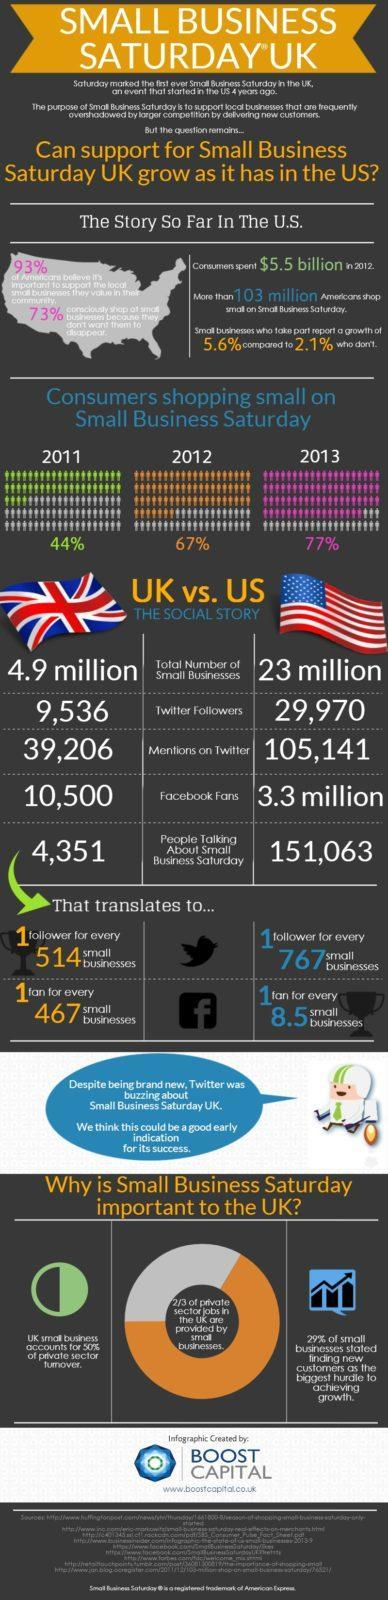What percentage of consumers were shopping small on Small Business Saturday in 2012?
Answer the question with a short phrase. 67% How many people were talking about the the Small Business Saturday in US? 151,063 What percentage of consumers were shopping small on Small Business Saturday in 2013? 77% How many fans are in facebook for every 467 small businesses in UK? 1 How many twitter mentions were received by the Small Business Saturday in UK? 39,206 How many twitter followers are there for the Small Business Saturday in UK? 9,536 What is the total number of small businesses that took part in Small Business Saturday in US? 23 MILLION What percentage of private sector turnover is contributed by the UK small business? 50% How many facebook fans are there for the Small Business Saturday in US? 3.3 million How many followers are in twitter for every 767 small businesses in US? 1 follower 